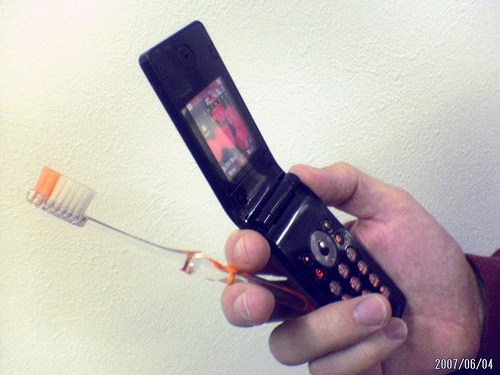Describe the objects in this image and their specific colors. I can see people in ivory, purple, navy, and darkgray tones, cell phone in ivory, navy, purple, and darkgray tones, and toothbrush in ivory, beige, darkgray, and tan tones in this image. 